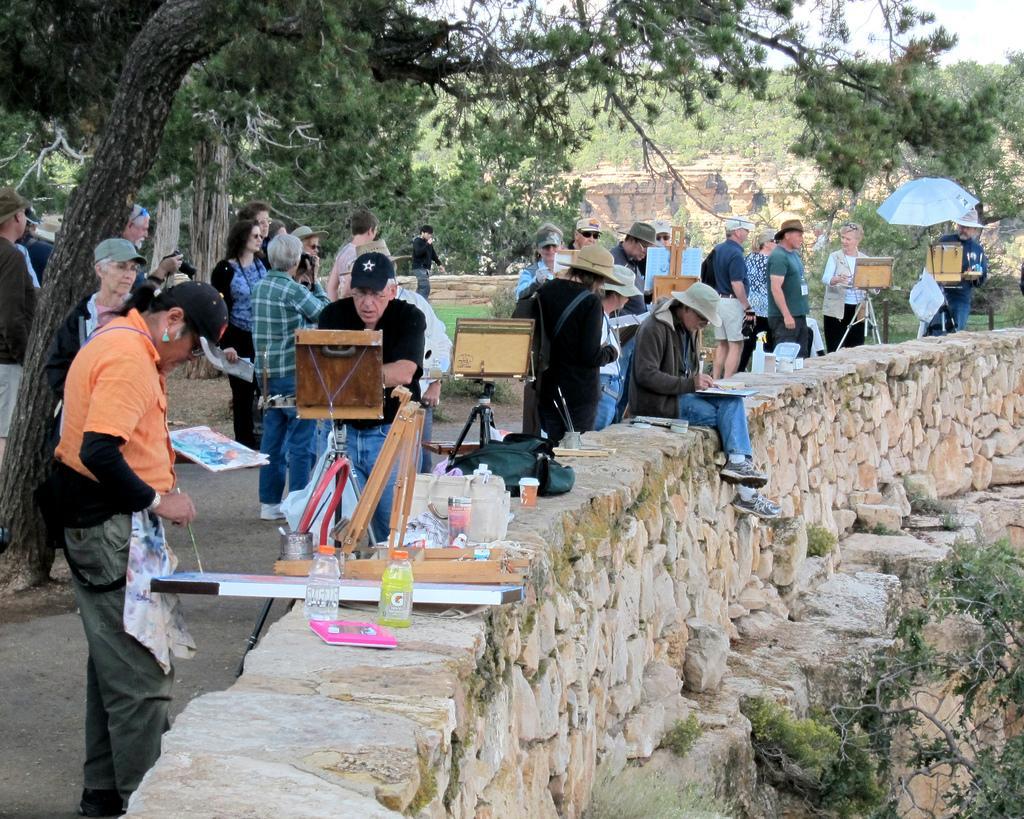Describe this image in one or two sentences. In this image there is a rock wall in the bottom of this image. There are some objects kept on it, and there is one person sitting on to this wall. There are some persons standing as we can see in the middle of this image. There are some trees in the background. There is a tree in the bottom right corner of this image. 